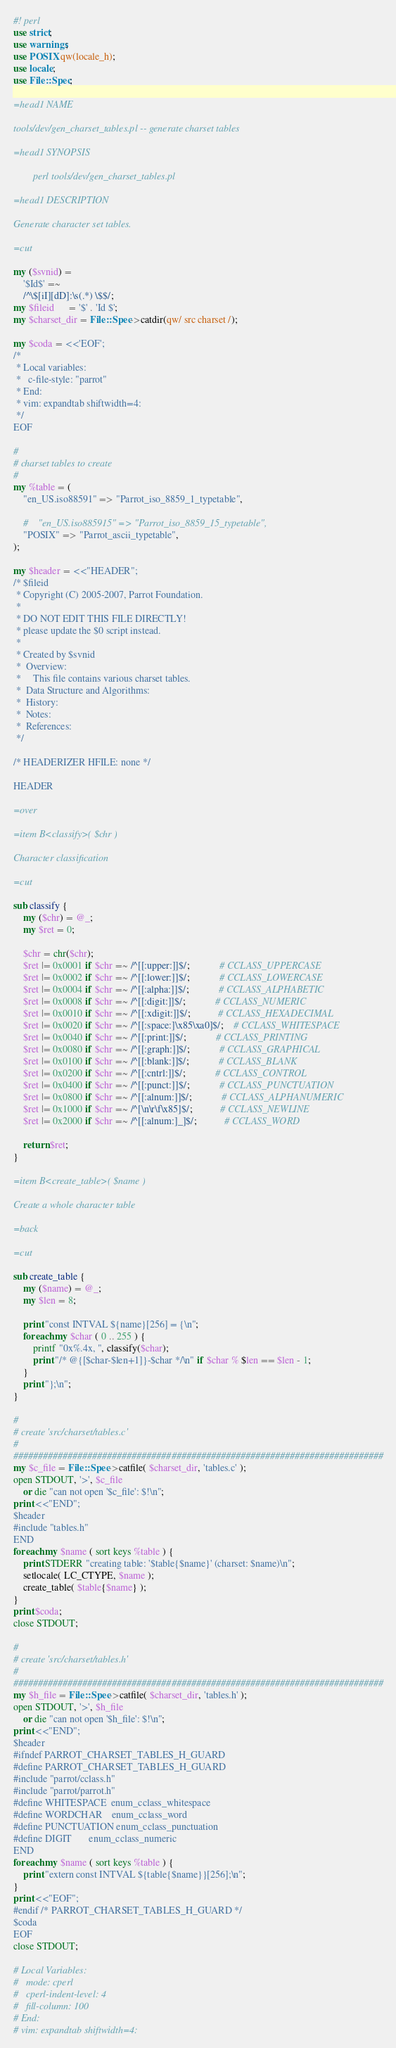<code> <loc_0><loc_0><loc_500><loc_500><_Perl_>#! perl
use strict;
use warnings;
use POSIX qw(locale_h);
use locale;
use File::Spec;

=head1 NAME

tools/dev/gen_charset_tables.pl -- generate charset tables

=head1 SYNOPSIS

        perl tools/dev/gen_charset_tables.pl

=head1 DESCRIPTION

Generate character set tables.

=cut

my ($svnid) =
    '$Id$' =~
    /^\$[iI][dD]:\s(.*) \$$/;
my $fileid      = '$' . 'Id $';
my $charset_dir = File::Spec->catdir(qw/ src charset /);

my $coda = <<'EOF';
/*
 * Local variables:
 *   c-file-style: "parrot"
 * End:
 * vim: expandtab shiftwidth=4:
 */
EOF

#
# charset tables to create
#
my %table = (
    "en_US.iso88591" => "Parrot_iso_8859_1_typetable",

    #    "en_US.iso885915" => "Parrot_iso_8859_15_typetable",
    "POSIX" => "Parrot_ascii_typetable",
);

my $header = <<"HEADER";
/* $fileid
 * Copyright (C) 2005-2007, Parrot Foundation.
 *
 * DO NOT EDIT THIS FILE DIRECTLY!
 * please update the $0 script instead.
 *
 * Created by $svnid
 *  Overview:
 *     This file contains various charset tables.
 *  Data Structure and Algorithms:
 *  History:
 *  Notes:
 *  References:
 */

/* HEADERIZER HFILE: none */

HEADER

=over

=item B<classify>( $chr )

Character classification

=cut

sub classify {
    my ($chr) = @_;
    my $ret = 0;

    $chr = chr($chr);
    $ret |= 0x0001 if $chr =~ /^[[:upper:]]$/;            # CCLASS_UPPERCASE
    $ret |= 0x0002 if $chr =~ /^[[:lower:]]$/;            # CCLASS_LOWERCASE
    $ret |= 0x0004 if $chr =~ /^[[:alpha:]]$/;            # CCLASS_ALPHABETIC
    $ret |= 0x0008 if $chr =~ /^[[:digit:]]$/;            # CCLASS_NUMERIC
    $ret |= 0x0010 if $chr =~ /^[[:xdigit:]]$/;           # CCLASS_HEXADECIMAL
    $ret |= 0x0020 if $chr =~ /^[[:space:]\x85\xa0]$/;    # CCLASS_WHITESPACE
    $ret |= 0x0040 if $chr =~ /^[[:print:]]$/;            # CCLASS_PRINTING
    $ret |= 0x0080 if $chr =~ /^[[:graph:]]$/;            # CCLASS_GRAPHICAL
    $ret |= 0x0100 if $chr =~ /^[[:blank:]]$/;            # CCLASS_BLANK
    $ret |= 0x0200 if $chr =~ /^[[:cntrl:]]$/;            # CCLASS_CONTROL
    $ret |= 0x0400 if $chr =~ /^[[:punct:]]$/;            # CCLASS_PUNCTUATION
    $ret |= 0x0800 if $chr =~ /^[[:alnum:]]$/;            # CCLASS_ALPHANUMERIC
    $ret |= 0x1000 if $chr =~ /^[\n\r\f\x85]$/;           # CCLASS_NEWLINE
    $ret |= 0x2000 if $chr =~ /^[[:alnum:]_]$/;           # CCLASS_WORD

    return $ret;
}

=item B<create_table>( $name )

Create a whole character table

=back

=cut

sub create_table {
    my ($name) = @_;
    my $len = 8;

    print "const INTVAL ${name}[256] = {\n";
    foreach my $char ( 0 .. 255 ) {
        printf "0x%.4x, ", classify($char);
        print "/* @{[$char-$len+1]}-$char */\n" if $char % $len == $len - 1;
    }
    print "};\n";
}

#
# create 'src/charset/tables.c'
#
###########################################################################
my $c_file = File::Spec->catfile( $charset_dir, 'tables.c' );
open STDOUT, '>', $c_file
    or die "can not open '$c_file': $!\n";
print <<"END";
$header
#include "tables.h"
END
foreach my $name ( sort keys %table ) {
    print STDERR "creating table: '$table{$name}' (charset: $name)\n";
    setlocale( LC_CTYPE, $name );
    create_table( $table{$name} );
}
print $coda;
close STDOUT;

#
# create 'src/charset/tables.h'
#
###########################################################################
my $h_file = File::Spec->catfile( $charset_dir, 'tables.h' );
open STDOUT, '>', $h_file
    or die "can not open '$h_file': $!\n";
print <<"END";
$header
#ifndef PARROT_CHARSET_TABLES_H_GUARD
#define PARROT_CHARSET_TABLES_H_GUARD
#include "parrot/cclass.h"
#include "parrot/parrot.h"
#define WHITESPACE  enum_cclass_whitespace
#define WORDCHAR    enum_cclass_word
#define PUNCTUATION enum_cclass_punctuation
#define DIGIT       enum_cclass_numeric
END
foreach my $name ( sort keys %table ) {
    print "extern const INTVAL ${table{$name}}[256];\n";
}
print <<"EOF";
#endif /* PARROT_CHARSET_TABLES_H_GUARD */
$coda
EOF
close STDOUT;

# Local Variables:
#   mode: cperl
#   cperl-indent-level: 4
#   fill-column: 100
# End:
# vim: expandtab shiftwidth=4:
</code> 